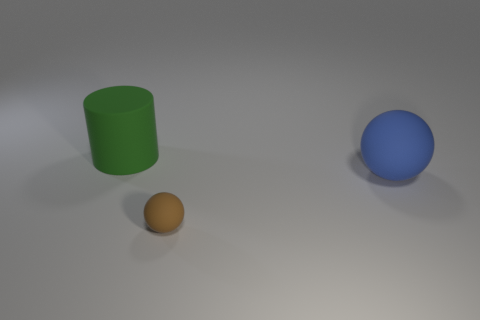Are the blue ball and the large object behind the big blue ball made of the same material?
Offer a very short reply. Yes. Is there a small sphere that has the same color as the large matte cylinder?
Offer a very short reply. No. How many other objects are the same material as the big ball?
Your answer should be compact. 2. There is a small thing; is its color the same as the big rubber object on the left side of the blue rubber object?
Make the answer very short. No. Are there more matte balls that are right of the tiny rubber sphere than large green rubber things?
Give a very brief answer. No. What number of large blue matte balls are in front of the big matte thing in front of the big thing to the left of the brown matte object?
Offer a terse response. 0. Does the object that is behind the big blue rubber object have the same shape as the brown thing?
Give a very brief answer. No. What material is the big object that is right of the green cylinder?
Give a very brief answer. Rubber. There is a thing that is behind the small brown matte thing and in front of the large green cylinder; what is its shape?
Offer a very short reply. Sphere. What is the material of the big blue ball?
Your answer should be very brief. Rubber. 